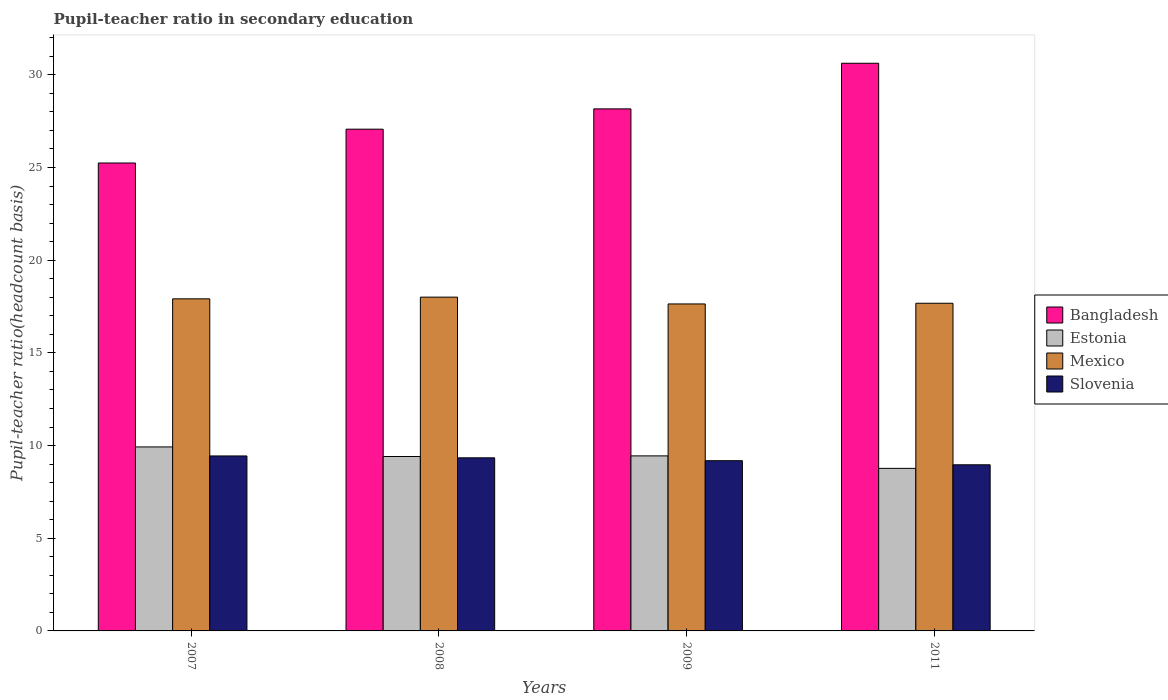How many different coloured bars are there?
Ensure brevity in your answer.  4. How many groups of bars are there?
Offer a very short reply. 4. What is the pupil-teacher ratio in secondary education in Bangladesh in 2011?
Keep it short and to the point. 30.62. Across all years, what is the maximum pupil-teacher ratio in secondary education in Bangladesh?
Your answer should be very brief. 30.62. Across all years, what is the minimum pupil-teacher ratio in secondary education in Estonia?
Keep it short and to the point. 8.77. In which year was the pupil-teacher ratio in secondary education in Mexico minimum?
Give a very brief answer. 2009. What is the total pupil-teacher ratio in secondary education in Mexico in the graph?
Offer a very short reply. 71.24. What is the difference between the pupil-teacher ratio in secondary education in Estonia in 2008 and that in 2009?
Ensure brevity in your answer.  -0.03. What is the difference between the pupil-teacher ratio in secondary education in Estonia in 2007 and the pupil-teacher ratio in secondary education in Mexico in 2009?
Make the answer very short. -7.71. What is the average pupil-teacher ratio in secondary education in Bangladesh per year?
Make the answer very short. 27.78. In the year 2007, what is the difference between the pupil-teacher ratio in secondary education in Mexico and pupil-teacher ratio in secondary education in Estonia?
Your answer should be compact. 7.99. In how many years, is the pupil-teacher ratio in secondary education in Slovenia greater than 6?
Offer a terse response. 4. What is the ratio of the pupil-teacher ratio in secondary education in Bangladesh in 2009 to that in 2011?
Give a very brief answer. 0.92. What is the difference between the highest and the second highest pupil-teacher ratio in secondary education in Bangladesh?
Ensure brevity in your answer.  2.46. What is the difference between the highest and the lowest pupil-teacher ratio in secondary education in Slovenia?
Offer a very short reply. 0.48. Is the sum of the pupil-teacher ratio in secondary education in Mexico in 2008 and 2009 greater than the maximum pupil-teacher ratio in secondary education in Slovenia across all years?
Provide a succinct answer. Yes. What does the 4th bar from the left in 2007 represents?
Give a very brief answer. Slovenia. What does the 2nd bar from the right in 2011 represents?
Offer a very short reply. Mexico. How many bars are there?
Offer a very short reply. 16. Are the values on the major ticks of Y-axis written in scientific E-notation?
Your answer should be compact. No. Does the graph contain grids?
Provide a succinct answer. No. Where does the legend appear in the graph?
Your answer should be very brief. Center right. How many legend labels are there?
Provide a succinct answer. 4. How are the legend labels stacked?
Ensure brevity in your answer.  Vertical. What is the title of the graph?
Your answer should be very brief. Pupil-teacher ratio in secondary education. Does "Philippines" appear as one of the legend labels in the graph?
Keep it short and to the point. No. What is the label or title of the Y-axis?
Provide a short and direct response. Pupil-teacher ratio(headcount basis). What is the Pupil-teacher ratio(headcount basis) of Bangladesh in 2007?
Your answer should be very brief. 25.24. What is the Pupil-teacher ratio(headcount basis) of Estonia in 2007?
Make the answer very short. 9.93. What is the Pupil-teacher ratio(headcount basis) in Mexico in 2007?
Provide a short and direct response. 17.92. What is the Pupil-teacher ratio(headcount basis) of Slovenia in 2007?
Provide a short and direct response. 9.44. What is the Pupil-teacher ratio(headcount basis) of Bangladesh in 2008?
Provide a succinct answer. 27.07. What is the Pupil-teacher ratio(headcount basis) of Estonia in 2008?
Give a very brief answer. 9.41. What is the Pupil-teacher ratio(headcount basis) in Mexico in 2008?
Keep it short and to the point. 18.01. What is the Pupil-teacher ratio(headcount basis) in Slovenia in 2008?
Your answer should be very brief. 9.34. What is the Pupil-teacher ratio(headcount basis) of Bangladesh in 2009?
Provide a short and direct response. 28.16. What is the Pupil-teacher ratio(headcount basis) in Estonia in 2009?
Provide a short and direct response. 9.44. What is the Pupil-teacher ratio(headcount basis) in Mexico in 2009?
Make the answer very short. 17.64. What is the Pupil-teacher ratio(headcount basis) in Slovenia in 2009?
Offer a very short reply. 9.18. What is the Pupil-teacher ratio(headcount basis) of Bangladesh in 2011?
Offer a very short reply. 30.62. What is the Pupil-teacher ratio(headcount basis) of Estonia in 2011?
Make the answer very short. 8.77. What is the Pupil-teacher ratio(headcount basis) in Mexico in 2011?
Ensure brevity in your answer.  17.68. What is the Pupil-teacher ratio(headcount basis) of Slovenia in 2011?
Keep it short and to the point. 8.96. Across all years, what is the maximum Pupil-teacher ratio(headcount basis) of Bangladesh?
Offer a very short reply. 30.62. Across all years, what is the maximum Pupil-teacher ratio(headcount basis) of Estonia?
Your answer should be very brief. 9.93. Across all years, what is the maximum Pupil-teacher ratio(headcount basis) in Mexico?
Offer a terse response. 18.01. Across all years, what is the maximum Pupil-teacher ratio(headcount basis) of Slovenia?
Provide a short and direct response. 9.44. Across all years, what is the minimum Pupil-teacher ratio(headcount basis) of Bangladesh?
Offer a very short reply. 25.24. Across all years, what is the minimum Pupil-teacher ratio(headcount basis) of Estonia?
Provide a succinct answer. 8.77. Across all years, what is the minimum Pupil-teacher ratio(headcount basis) of Mexico?
Provide a succinct answer. 17.64. Across all years, what is the minimum Pupil-teacher ratio(headcount basis) of Slovenia?
Provide a short and direct response. 8.96. What is the total Pupil-teacher ratio(headcount basis) in Bangladesh in the graph?
Your answer should be compact. 111.1. What is the total Pupil-teacher ratio(headcount basis) of Estonia in the graph?
Offer a terse response. 37.55. What is the total Pupil-teacher ratio(headcount basis) in Mexico in the graph?
Make the answer very short. 71.24. What is the total Pupil-teacher ratio(headcount basis) of Slovenia in the graph?
Give a very brief answer. 36.92. What is the difference between the Pupil-teacher ratio(headcount basis) in Bangladesh in 2007 and that in 2008?
Provide a succinct answer. -1.82. What is the difference between the Pupil-teacher ratio(headcount basis) of Estonia in 2007 and that in 2008?
Provide a short and direct response. 0.52. What is the difference between the Pupil-teacher ratio(headcount basis) in Mexico in 2007 and that in 2008?
Provide a short and direct response. -0.09. What is the difference between the Pupil-teacher ratio(headcount basis) of Slovenia in 2007 and that in 2008?
Provide a succinct answer. 0.1. What is the difference between the Pupil-teacher ratio(headcount basis) of Bangladesh in 2007 and that in 2009?
Give a very brief answer. -2.92. What is the difference between the Pupil-teacher ratio(headcount basis) in Estonia in 2007 and that in 2009?
Provide a short and direct response. 0.48. What is the difference between the Pupil-teacher ratio(headcount basis) of Mexico in 2007 and that in 2009?
Your response must be concise. 0.28. What is the difference between the Pupil-teacher ratio(headcount basis) in Slovenia in 2007 and that in 2009?
Your answer should be compact. 0.26. What is the difference between the Pupil-teacher ratio(headcount basis) of Bangladesh in 2007 and that in 2011?
Ensure brevity in your answer.  -5.38. What is the difference between the Pupil-teacher ratio(headcount basis) in Estonia in 2007 and that in 2011?
Provide a short and direct response. 1.16. What is the difference between the Pupil-teacher ratio(headcount basis) in Mexico in 2007 and that in 2011?
Your answer should be very brief. 0.24. What is the difference between the Pupil-teacher ratio(headcount basis) of Slovenia in 2007 and that in 2011?
Offer a terse response. 0.48. What is the difference between the Pupil-teacher ratio(headcount basis) in Bangladesh in 2008 and that in 2009?
Provide a succinct answer. -1.1. What is the difference between the Pupil-teacher ratio(headcount basis) of Estonia in 2008 and that in 2009?
Your answer should be very brief. -0.03. What is the difference between the Pupil-teacher ratio(headcount basis) of Mexico in 2008 and that in 2009?
Your answer should be compact. 0.37. What is the difference between the Pupil-teacher ratio(headcount basis) in Slovenia in 2008 and that in 2009?
Your response must be concise. 0.16. What is the difference between the Pupil-teacher ratio(headcount basis) in Bangladesh in 2008 and that in 2011?
Provide a short and direct response. -3.56. What is the difference between the Pupil-teacher ratio(headcount basis) in Estonia in 2008 and that in 2011?
Offer a terse response. 0.64. What is the difference between the Pupil-teacher ratio(headcount basis) in Mexico in 2008 and that in 2011?
Keep it short and to the point. 0.33. What is the difference between the Pupil-teacher ratio(headcount basis) of Slovenia in 2008 and that in 2011?
Your response must be concise. 0.38. What is the difference between the Pupil-teacher ratio(headcount basis) of Bangladesh in 2009 and that in 2011?
Your response must be concise. -2.46. What is the difference between the Pupil-teacher ratio(headcount basis) of Estonia in 2009 and that in 2011?
Offer a very short reply. 0.67. What is the difference between the Pupil-teacher ratio(headcount basis) of Mexico in 2009 and that in 2011?
Your answer should be compact. -0.04. What is the difference between the Pupil-teacher ratio(headcount basis) in Slovenia in 2009 and that in 2011?
Offer a terse response. 0.22. What is the difference between the Pupil-teacher ratio(headcount basis) in Bangladesh in 2007 and the Pupil-teacher ratio(headcount basis) in Estonia in 2008?
Provide a short and direct response. 15.84. What is the difference between the Pupil-teacher ratio(headcount basis) of Bangladesh in 2007 and the Pupil-teacher ratio(headcount basis) of Mexico in 2008?
Offer a very short reply. 7.24. What is the difference between the Pupil-teacher ratio(headcount basis) in Bangladesh in 2007 and the Pupil-teacher ratio(headcount basis) in Slovenia in 2008?
Your answer should be very brief. 15.91. What is the difference between the Pupil-teacher ratio(headcount basis) in Estonia in 2007 and the Pupil-teacher ratio(headcount basis) in Mexico in 2008?
Your response must be concise. -8.08. What is the difference between the Pupil-teacher ratio(headcount basis) in Estonia in 2007 and the Pupil-teacher ratio(headcount basis) in Slovenia in 2008?
Keep it short and to the point. 0.59. What is the difference between the Pupil-teacher ratio(headcount basis) of Mexico in 2007 and the Pupil-teacher ratio(headcount basis) of Slovenia in 2008?
Provide a succinct answer. 8.58. What is the difference between the Pupil-teacher ratio(headcount basis) in Bangladesh in 2007 and the Pupil-teacher ratio(headcount basis) in Estonia in 2009?
Your answer should be compact. 15.8. What is the difference between the Pupil-teacher ratio(headcount basis) in Bangladesh in 2007 and the Pupil-teacher ratio(headcount basis) in Mexico in 2009?
Offer a terse response. 7.6. What is the difference between the Pupil-teacher ratio(headcount basis) in Bangladesh in 2007 and the Pupil-teacher ratio(headcount basis) in Slovenia in 2009?
Keep it short and to the point. 16.06. What is the difference between the Pupil-teacher ratio(headcount basis) in Estonia in 2007 and the Pupil-teacher ratio(headcount basis) in Mexico in 2009?
Offer a very short reply. -7.71. What is the difference between the Pupil-teacher ratio(headcount basis) of Estonia in 2007 and the Pupil-teacher ratio(headcount basis) of Slovenia in 2009?
Give a very brief answer. 0.74. What is the difference between the Pupil-teacher ratio(headcount basis) of Mexico in 2007 and the Pupil-teacher ratio(headcount basis) of Slovenia in 2009?
Offer a terse response. 8.73. What is the difference between the Pupil-teacher ratio(headcount basis) of Bangladesh in 2007 and the Pupil-teacher ratio(headcount basis) of Estonia in 2011?
Provide a short and direct response. 16.47. What is the difference between the Pupil-teacher ratio(headcount basis) of Bangladesh in 2007 and the Pupil-teacher ratio(headcount basis) of Mexico in 2011?
Ensure brevity in your answer.  7.57. What is the difference between the Pupil-teacher ratio(headcount basis) in Bangladesh in 2007 and the Pupil-teacher ratio(headcount basis) in Slovenia in 2011?
Your answer should be very brief. 16.28. What is the difference between the Pupil-teacher ratio(headcount basis) in Estonia in 2007 and the Pupil-teacher ratio(headcount basis) in Mexico in 2011?
Provide a succinct answer. -7.75. What is the difference between the Pupil-teacher ratio(headcount basis) of Estonia in 2007 and the Pupil-teacher ratio(headcount basis) of Slovenia in 2011?
Offer a very short reply. 0.96. What is the difference between the Pupil-teacher ratio(headcount basis) in Mexico in 2007 and the Pupil-teacher ratio(headcount basis) in Slovenia in 2011?
Provide a short and direct response. 8.95. What is the difference between the Pupil-teacher ratio(headcount basis) of Bangladesh in 2008 and the Pupil-teacher ratio(headcount basis) of Estonia in 2009?
Offer a terse response. 17.62. What is the difference between the Pupil-teacher ratio(headcount basis) of Bangladesh in 2008 and the Pupil-teacher ratio(headcount basis) of Mexico in 2009?
Keep it short and to the point. 9.43. What is the difference between the Pupil-teacher ratio(headcount basis) in Bangladesh in 2008 and the Pupil-teacher ratio(headcount basis) in Slovenia in 2009?
Your answer should be compact. 17.89. What is the difference between the Pupil-teacher ratio(headcount basis) in Estonia in 2008 and the Pupil-teacher ratio(headcount basis) in Mexico in 2009?
Give a very brief answer. -8.23. What is the difference between the Pupil-teacher ratio(headcount basis) of Estonia in 2008 and the Pupil-teacher ratio(headcount basis) of Slovenia in 2009?
Your answer should be compact. 0.23. What is the difference between the Pupil-teacher ratio(headcount basis) in Mexico in 2008 and the Pupil-teacher ratio(headcount basis) in Slovenia in 2009?
Make the answer very short. 8.82. What is the difference between the Pupil-teacher ratio(headcount basis) in Bangladesh in 2008 and the Pupil-teacher ratio(headcount basis) in Estonia in 2011?
Your answer should be compact. 18.3. What is the difference between the Pupil-teacher ratio(headcount basis) of Bangladesh in 2008 and the Pupil-teacher ratio(headcount basis) of Mexico in 2011?
Offer a very short reply. 9.39. What is the difference between the Pupil-teacher ratio(headcount basis) in Bangladesh in 2008 and the Pupil-teacher ratio(headcount basis) in Slovenia in 2011?
Give a very brief answer. 18.11. What is the difference between the Pupil-teacher ratio(headcount basis) in Estonia in 2008 and the Pupil-teacher ratio(headcount basis) in Mexico in 2011?
Your response must be concise. -8.27. What is the difference between the Pupil-teacher ratio(headcount basis) in Estonia in 2008 and the Pupil-teacher ratio(headcount basis) in Slovenia in 2011?
Make the answer very short. 0.45. What is the difference between the Pupil-teacher ratio(headcount basis) of Mexico in 2008 and the Pupil-teacher ratio(headcount basis) of Slovenia in 2011?
Keep it short and to the point. 9.04. What is the difference between the Pupil-teacher ratio(headcount basis) in Bangladesh in 2009 and the Pupil-teacher ratio(headcount basis) in Estonia in 2011?
Offer a very short reply. 19.39. What is the difference between the Pupil-teacher ratio(headcount basis) in Bangladesh in 2009 and the Pupil-teacher ratio(headcount basis) in Mexico in 2011?
Your response must be concise. 10.49. What is the difference between the Pupil-teacher ratio(headcount basis) of Bangladesh in 2009 and the Pupil-teacher ratio(headcount basis) of Slovenia in 2011?
Provide a succinct answer. 19.2. What is the difference between the Pupil-teacher ratio(headcount basis) in Estonia in 2009 and the Pupil-teacher ratio(headcount basis) in Mexico in 2011?
Ensure brevity in your answer.  -8.23. What is the difference between the Pupil-teacher ratio(headcount basis) in Estonia in 2009 and the Pupil-teacher ratio(headcount basis) in Slovenia in 2011?
Your answer should be very brief. 0.48. What is the difference between the Pupil-teacher ratio(headcount basis) in Mexico in 2009 and the Pupil-teacher ratio(headcount basis) in Slovenia in 2011?
Provide a short and direct response. 8.68. What is the average Pupil-teacher ratio(headcount basis) of Bangladesh per year?
Offer a very short reply. 27.78. What is the average Pupil-teacher ratio(headcount basis) of Estonia per year?
Offer a terse response. 9.39. What is the average Pupil-teacher ratio(headcount basis) of Mexico per year?
Offer a terse response. 17.81. What is the average Pupil-teacher ratio(headcount basis) of Slovenia per year?
Your answer should be compact. 9.23. In the year 2007, what is the difference between the Pupil-teacher ratio(headcount basis) of Bangladesh and Pupil-teacher ratio(headcount basis) of Estonia?
Ensure brevity in your answer.  15.32. In the year 2007, what is the difference between the Pupil-teacher ratio(headcount basis) of Bangladesh and Pupil-teacher ratio(headcount basis) of Mexico?
Provide a succinct answer. 7.33. In the year 2007, what is the difference between the Pupil-teacher ratio(headcount basis) of Bangladesh and Pupil-teacher ratio(headcount basis) of Slovenia?
Make the answer very short. 15.8. In the year 2007, what is the difference between the Pupil-teacher ratio(headcount basis) of Estonia and Pupil-teacher ratio(headcount basis) of Mexico?
Keep it short and to the point. -7.99. In the year 2007, what is the difference between the Pupil-teacher ratio(headcount basis) of Estonia and Pupil-teacher ratio(headcount basis) of Slovenia?
Keep it short and to the point. 0.49. In the year 2007, what is the difference between the Pupil-teacher ratio(headcount basis) in Mexico and Pupil-teacher ratio(headcount basis) in Slovenia?
Your answer should be very brief. 8.48. In the year 2008, what is the difference between the Pupil-teacher ratio(headcount basis) in Bangladesh and Pupil-teacher ratio(headcount basis) in Estonia?
Provide a short and direct response. 17.66. In the year 2008, what is the difference between the Pupil-teacher ratio(headcount basis) of Bangladesh and Pupil-teacher ratio(headcount basis) of Mexico?
Offer a very short reply. 9.06. In the year 2008, what is the difference between the Pupil-teacher ratio(headcount basis) of Bangladesh and Pupil-teacher ratio(headcount basis) of Slovenia?
Provide a short and direct response. 17.73. In the year 2008, what is the difference between the Pupil-teacher ratio(headcount basis) of Estonia and Pupil-teacher ratio(headcount basis) of Mexico?
Offer a terse response. -8.6. In the year 2008, what is the difference between the Pupil-teacher ratio(headcount basis) in Estonia and Pupil-teacher ratio(headcount basis) in Slovenia?
Your answer should be compact. 0.07. In the year 2008, what is the difference between the Pupil-teacher ratio(headcount basis) of Mexico and Pupil-teacher ratio(headcount basis) of Slovenia?
Make the answer very short. 8.67. In the year 2009, what is the difference between the Pupil-teacher ratio(headcount basis) of Bangladesh and Pupil-teacher ratio(headcount basis) of Estonia?
Give a very brief answer. 18.72. In the year 2009, what is the difference between the Pupil-teacher ratio(headcount basis) in Bangladesh and Pupil-teacher ratio(headcount basis) in Mexico?
Provide a short and direct response. 10.52. In the year 2009, what is the difference between the Pupil-teacher ratio(headcount basis) of Bangladesh and Pupil-teacher ratio(headcount basis) of Slovenia?
Provide a short and direct response. 18.98. In the year 2009, what is the difference between the Pupil-teacher ratio(headcount basis) in Estonia and Pupil-teacher ratio(headcount basis) in Mexico?
Give a very brief answer. -8.2. In the year 2009, what is the difference between the Pupil-teacher ratio(headcount basis) of Estonia and Pupil-teacher ratio(headcount basis) of Slovenia?
Offer a very short reply. 0.26. In the year 2009, what is the difference between the Pupil-teacher ratio(headcount basis) in Mexico and Pupil-teacher ratio(headcount basis) in Slovenia?
Your response must be concise. 8.46. In the year 2011, what is the difference between the Pupil-teacher ratio(headcount basis) of Bangladesh and Pupil-teacher ratio(headcount basis) of Estonia?
Make the answer very short. 21.85. In the year 2011, what is the difference between the Pupil-teacher ratio(headcount basis) of Bangladesh and Pupil-teacher ratio(headcount basis) of Mexico?
Offer a terse response. 12.95. In the year 2011, what is the difference between the Pupil-teacher ratio(headcount basis) of Bangladesh and Pupil-teacher ratio(headcount basis) of Slovenia?
Your answer should be compact. 21.66. In the year 2011, what is the difference between the Pupil-teacher ratio(headcount basis) of Estonia and Pupil-teacher ratio(headcount basis) of Mexico?
Make the answer very short. -8.91. In the year 2011, what is the difference between the Pupil-teacher ratio(headcount basis) in Estonia and Pupil-teacher ratio(headcount basis) in Slovenia?
Your answer should be compact. -0.19. In the year 2011, what is the difference between the Pupil-teacher ratio(headcount basis) of Mexico and Pupil-teacher ratio(headcount basis) of Slovenia?
Offer a very short reply. 8.71. What is the ratio of the Pupil-teacher ratio(headcount basis) in Bangladesh in 2007 to that in 2008?
Keep it short and to the point. 0.93. What is the ratio of the Pupil-teacher ratio(headcount basis) in Estonia in 2007 to that in 2008?
Make the answer very short. 1.05. What is the ratio of the Pupil-teacher ratio(headcount basis) of Mexico in 2007 to that in 2008?
Offer a very short reply. 0.99. What is the ratio of the Pupil-teacher ratio(headcount basis) in Slovenia in 2007 to that in 2008?
Give a very brief answer. 1.01. What is the ratio of the Pupil-teacher ratio(headcount basis) of Bangladesh in 2007 to that in 2009?
Your response must be concise. 0.9. What is the ratio of the Pupil-teacher ratio(headcount basis) in Estonia in 2007 to that in 2009?
Give a very brief answer. 1.05. What is the ratio of the Pupil-teacher ratio(headcount basis) of Mexico in 2007 to that in 2009?
Provide a succinct answer. 1.02. What is the ratio of the Pupil-teacher ratio(headcount basis) in Slovenia in 2007 to that in 2009?
Offer a terse response. 1.03. What is the ratio of the Pupil-teacher ratio(headcount basis) in Bangladesh in 2007 to that in 2011?
Ensure brevity in your answer.  0.82. What is the ratio of the Pupil-teacher ratio(headcount basis) of Estonia in 2007 to that in 2011?
Give a very brief answer. 1.13. What is the ratio of the Pupil-teacher ratio(headcount basis) in Mexico in 2007 to that in 2011?
Your response must be concise. 1.01. What is the ratio of the Pupil-teacher ratio(headcount basis) in Slovenia in 2007 to that in 2011?
Provide a succinct answer. 1.05. What is the ratio of the Pupil-teacher ratio(headcount basis) in Bangladesh in 2008 to that in 2009?
Offer a terse response. 0.96. What is the ratio of the Pupil-teacher ratio(headcount basis) in Mexico in 2008 to that in 2009?
Your answer should be very brief. 1.02. What is the ratio of the Pupil-teacher ratio(headcount basis) of Bangladesh in 2008 to that in 2011?
Your answer should be very brief. 0.88. What is the ratio of the Pupil-teacher ratio(headcount basis) of Estonia in 2008 to that in 2011?
Your answer should be compact. 1.07. What is the ratio of the Pupil-teacher ratio(headcount basis) of Mexico in 2008 to that in 2011?
Offer a terse response. 1.02. What is the ratio of the Pupil-teacher ratio(headcount basis) in Slovenia in 2008 to that in 2011?
Ensure brevity in your answer.  1.04. What is the ratio of the Pupil-teacher ratio(headcount basis) in Bangladesh in 2009 to that in 2011?
Offer a terse response. 0.92. What is the ratio of the Pupil-teacher ratio(headcount basis) in Estonia in 2009 to that in 2011?
Give a very brief answer. 1.08. What is the ratio of the Pupil-teacher ratio(headcount basis) of Mexico in 2009 to that in 2011?
Provide a short and direct response. 1. What is the ratio of the Pupil-teacher ratio(headcount basis) of Slovenia in 2009 to that in 2011?
Your answer should be compact. 1.02. What is the difference between the highest and the second highest Pupil-teacher ratio(headcount basis) of Bangladesh?
Your response must be concise. 2.46. What is the difference between the highest and the second highest Pupil-teacher ratio(headcount basis) of Estonia?
Make the answer very short. 0.48. What is the difference between the highest and the second highest Pupil-teacher ratio(headcount basis) in Mexico?
Make the answer very short. 0.09. What is the difference between the highest and the second highest Pupil-teacher ratio(headcount basis) in Slovenia?
Your answer should be compact. 0.1. What is the difference between the highest and the lowest Pupil-teacher ratio(headcount basis) in Bangladesh?
Your answer should be very brief. 5.38. What is the difference between the highest and the lowest Pupil-teacher ratio(headcount basis) in Estonia?
Give a very brief answer. 1.16. What is the difference between the highest and the lowest Pupil-teacher ratio(headcount basis) in Mexico?
Your response must be concise. 0.37. What is the difference between the highest and the lowest Pupil-teacher ratio(headcount basis) of Slovenia?
Provide a short and direct response. 0.48. 